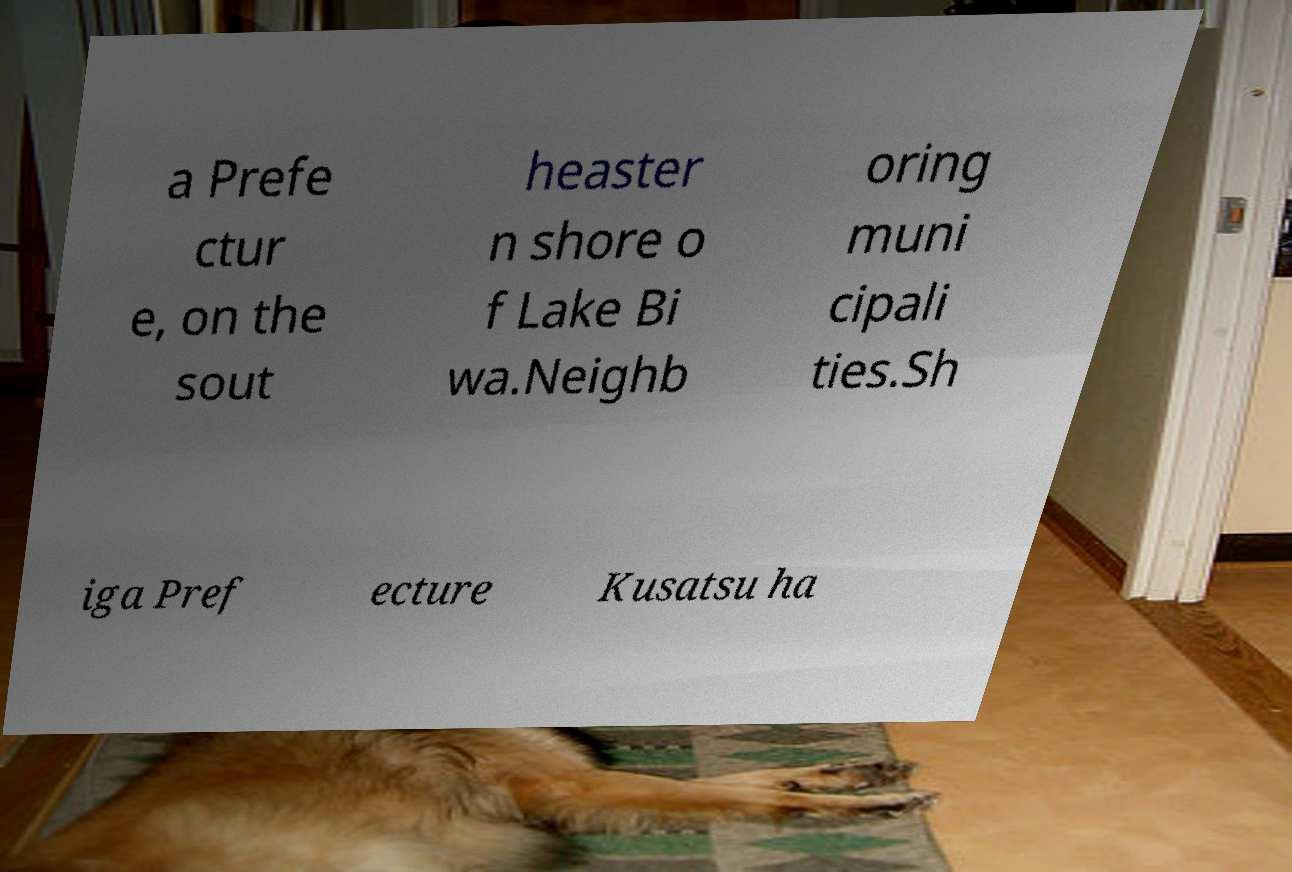Can you accurately transcribe the text from the provided image for me? a Prefe ctur e, on the sout heaster n shore o f Lake Bi wa.Neighb oring muni cipali ties.Sh iga Pref ecture Kusatsu ha 